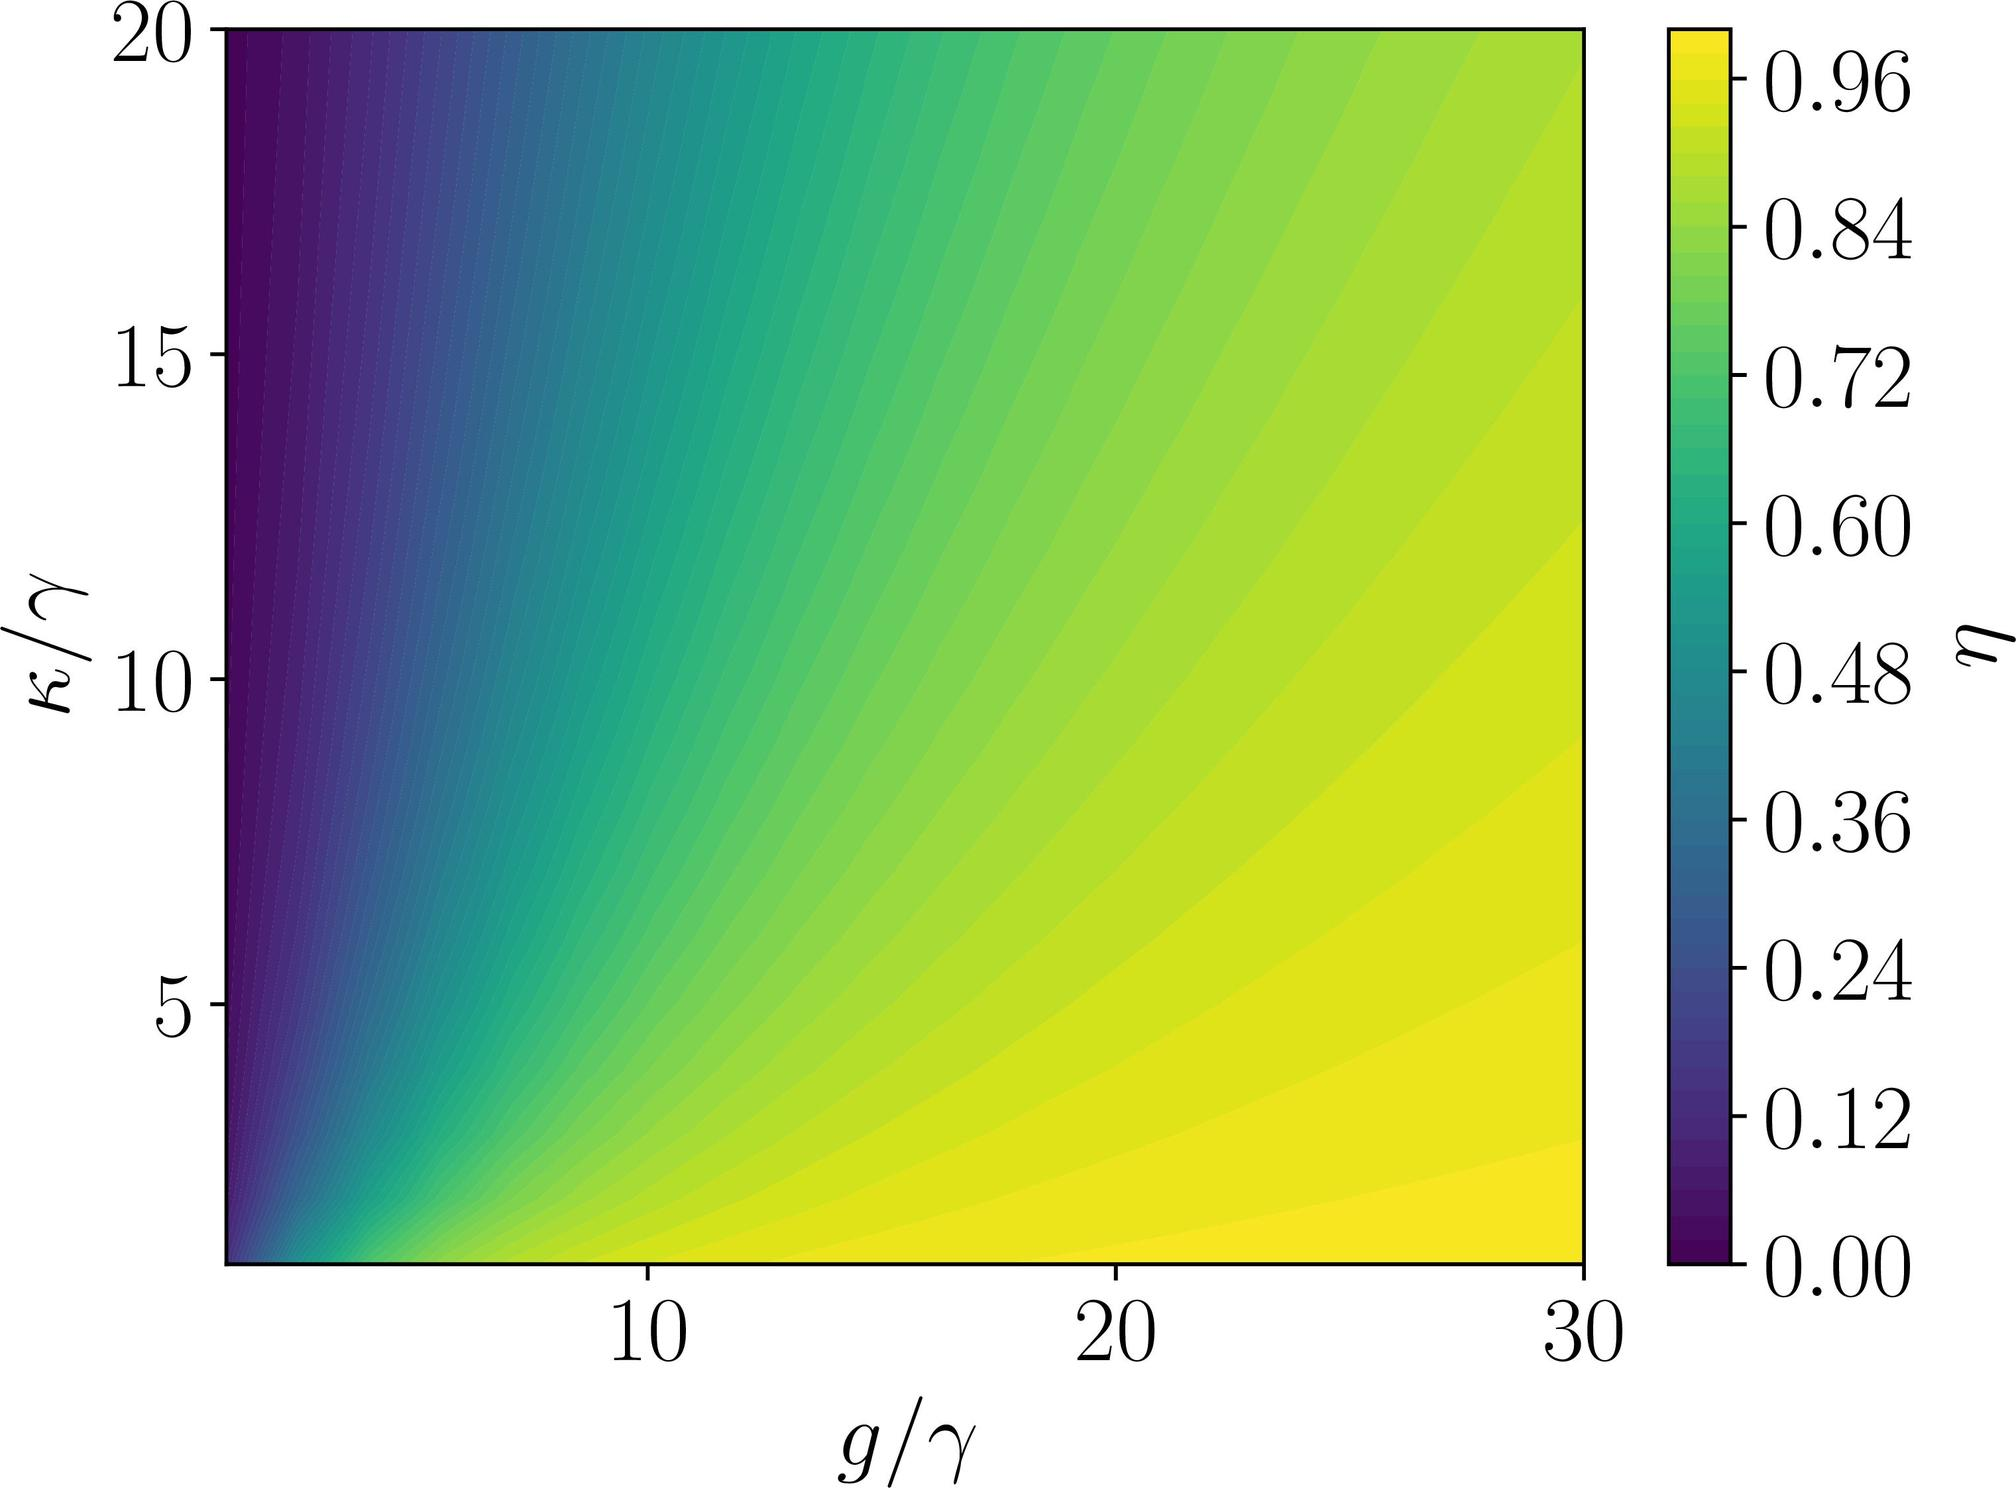If \( g/γ \) is increased from 10 to 20 while keeping \( κ/γ \) constant at 5, how does η change according to the figure? A) η increases B) η decreases C) η remains constant D) There is not enough information to determine As \( g/γ \) increases from 10 to 20 along the line where \( κ/γ = 5 \), the color transitions from yellow-green to dark blue, indicating that η decreases. Therefore, the correct answer is B. 